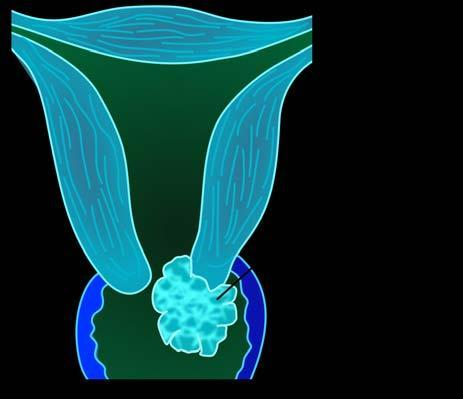what is of the cervix common gross appearance of or exophytic, cauliflower-like tumour?
Answer the question using a single word or phrase. Invasive carcinoma 